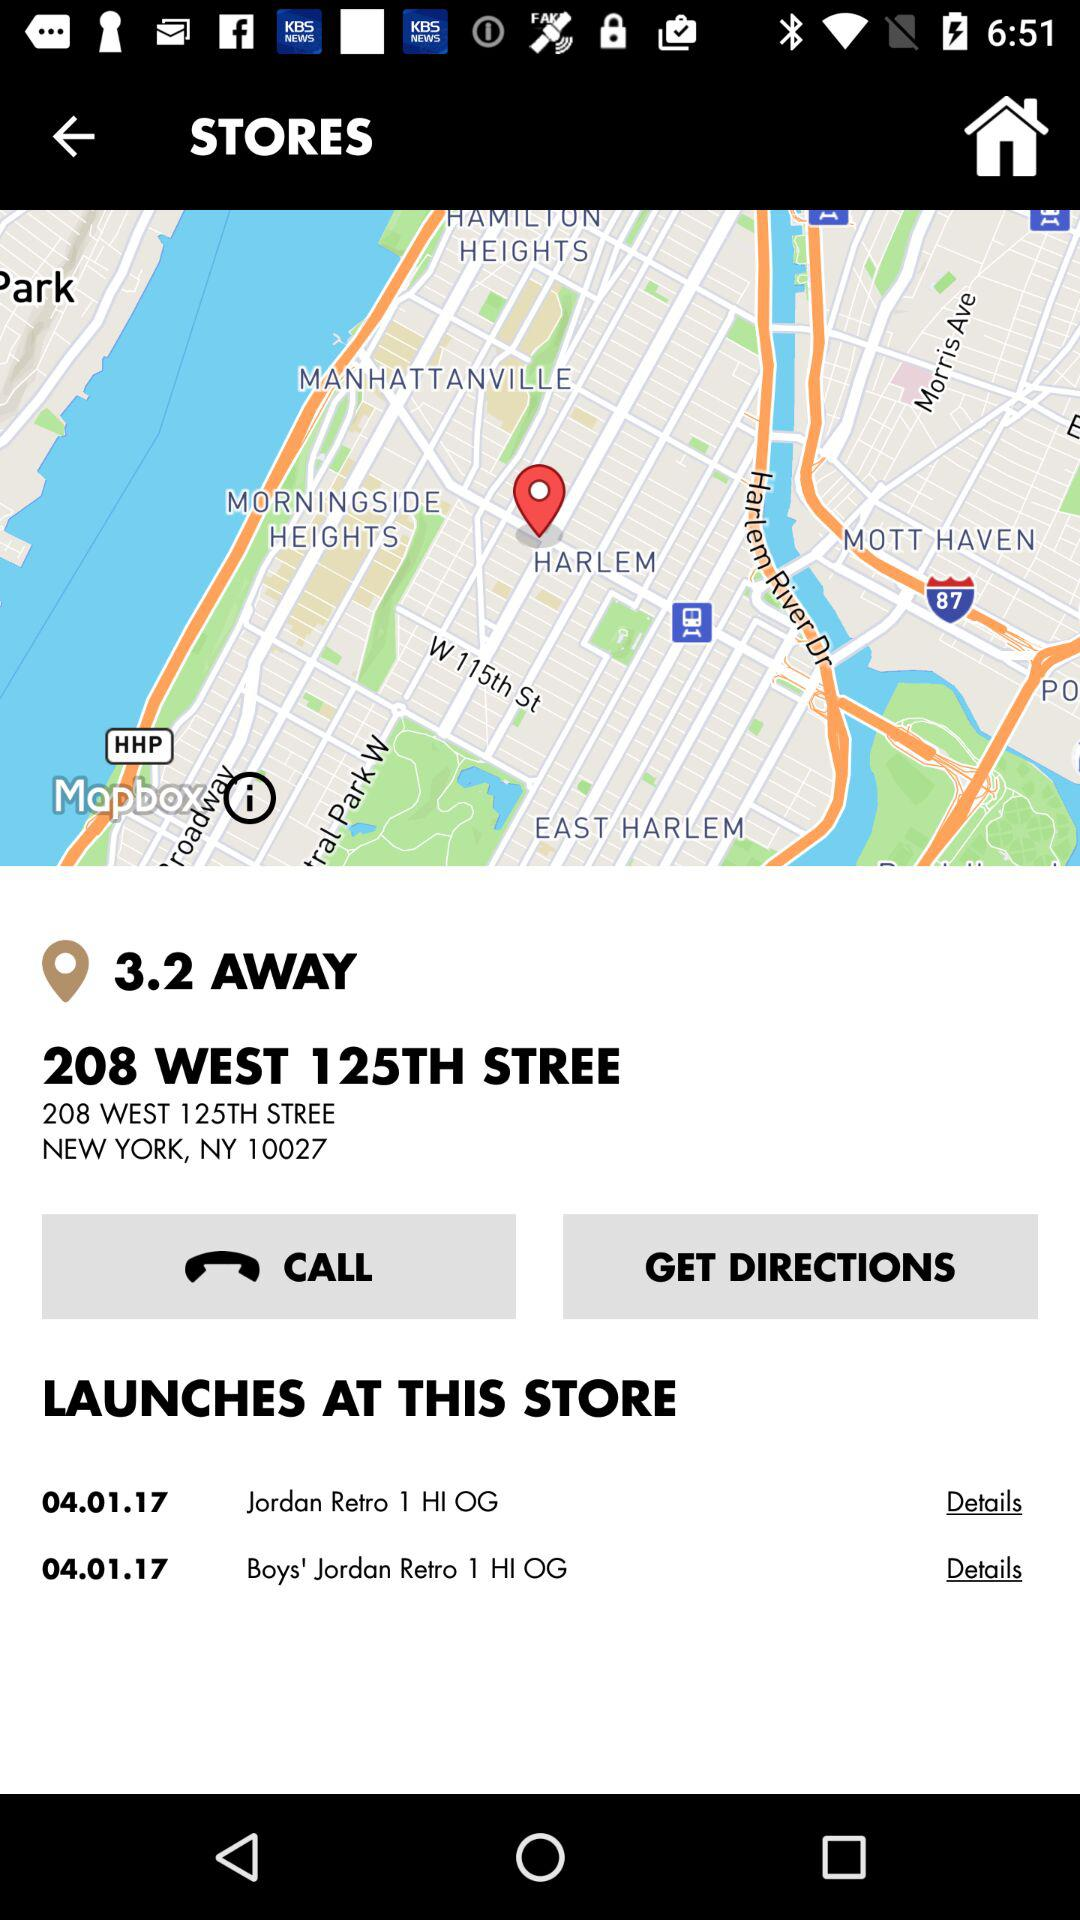How many items are available at this store?
Answer the question using a single word or phrase. 2 